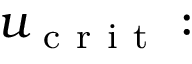<formula> <loc_0><loc_0><loc_500><loc_500>u _ { c r i t } \colon</formula> 